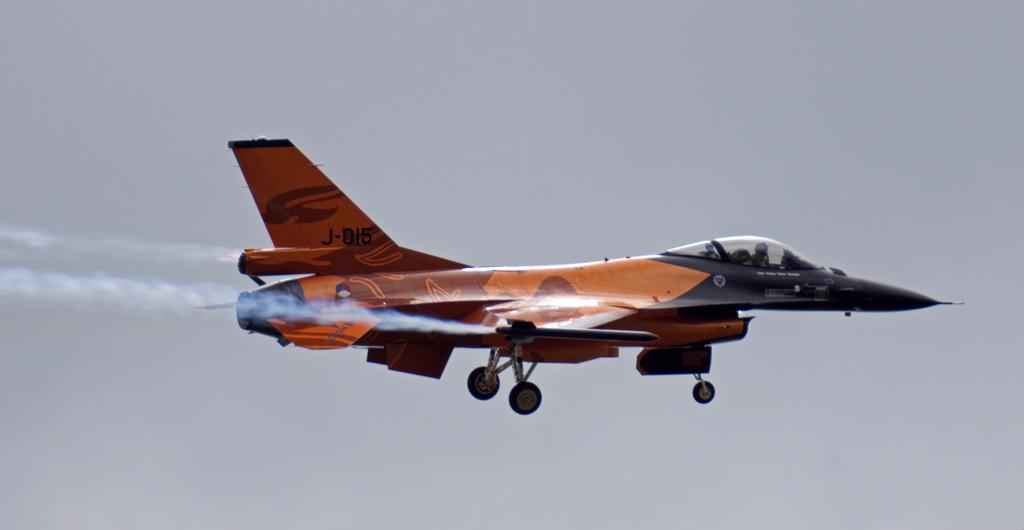What is the main subject of the image? The main subject of the image is an airplane. What is the airplane doing in the image? The airplane is flying. What can be seen in the background of the image? The sky is visible in the background of the image. What type of noise can be heard coming from the cemetery in the image? There is no cemetery present in the image, so it's not possible to determine what, if any, noise might be heard. 